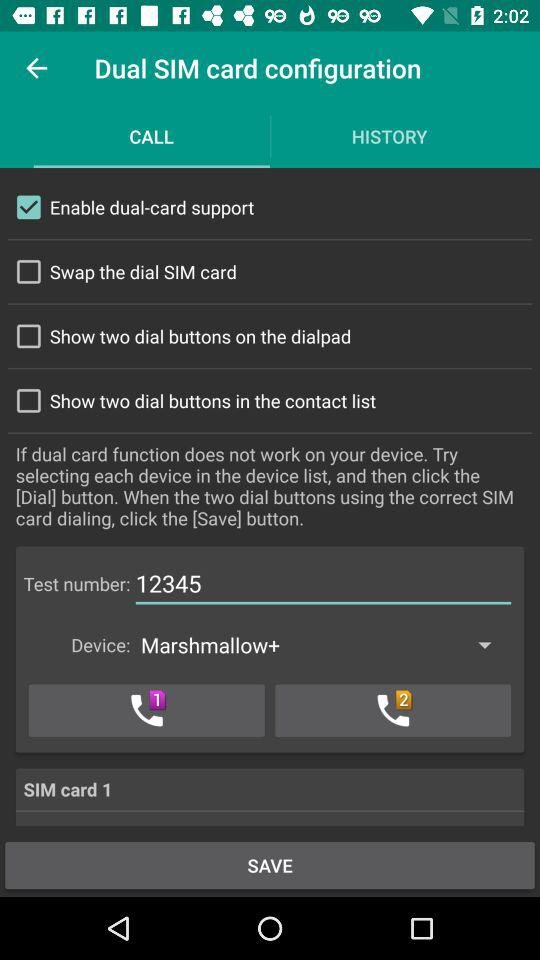Which device is selected? The selected device is "Marshmallow+". 